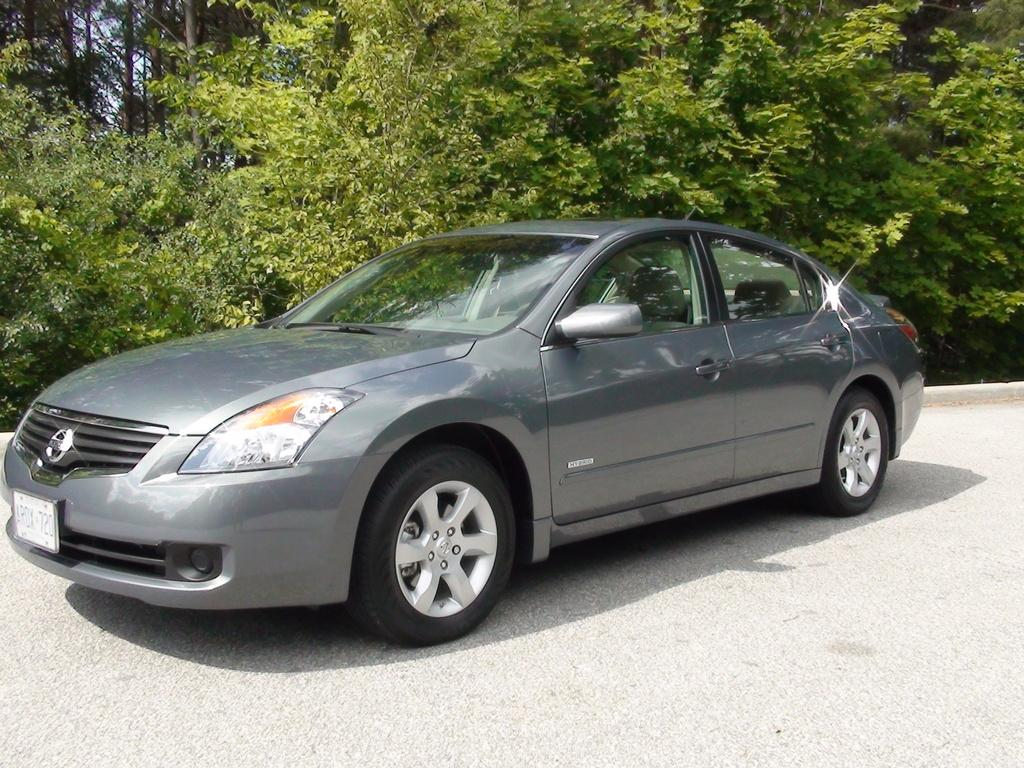<image>
Present a compact description of the photo's key features. a car that was made from the Nissan compabny 